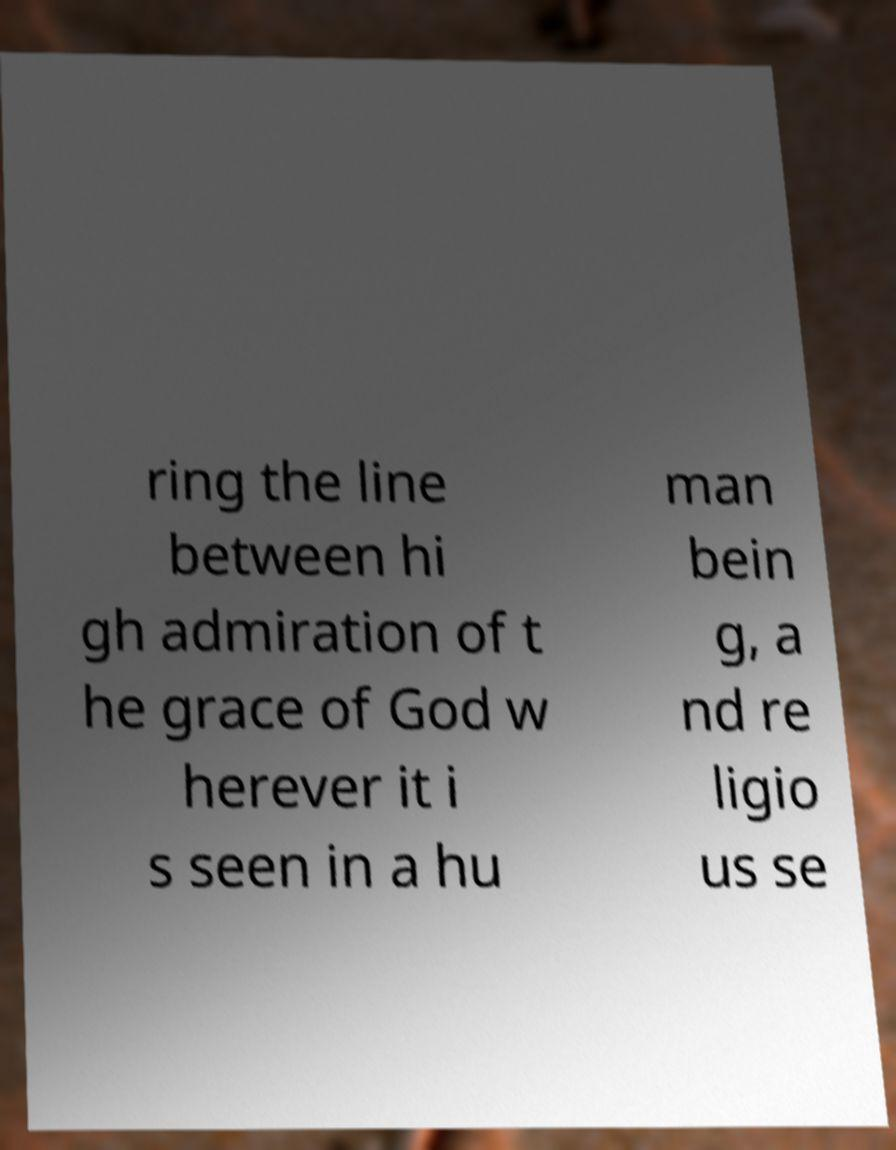I need the written content from this picture converted into text. Can you do that? ring the line between hi gh admiration of t he grace of God w herever it i s seen in a hu man bein g, a nd re ligio us se 